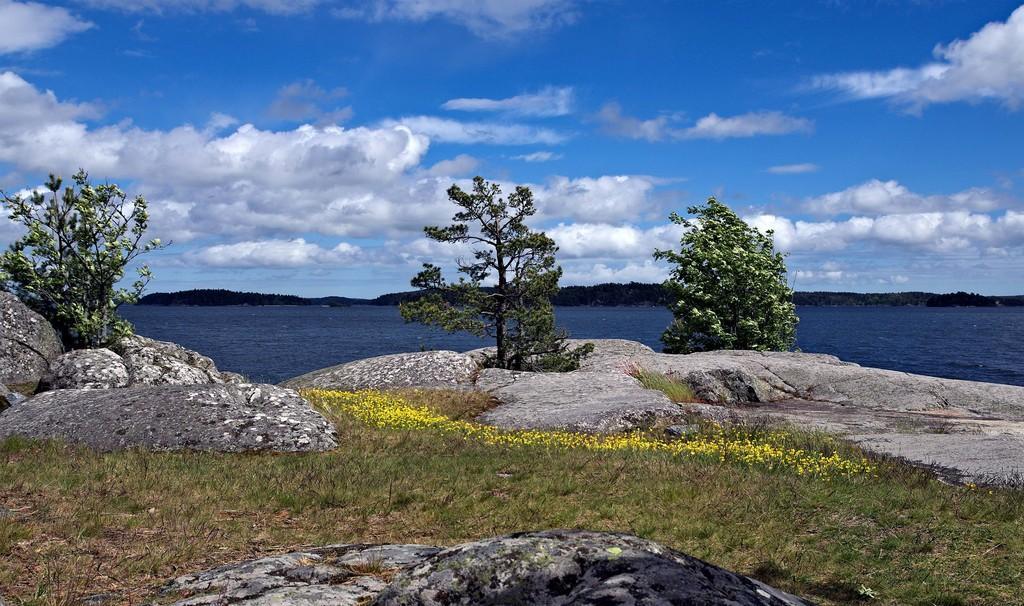Describe this image in one or two sentences. This image consists of water. At the bottom, we can see the rocks and green grass on the ground. In the middle, there are trees. At the top, there are clouds in the sky. 